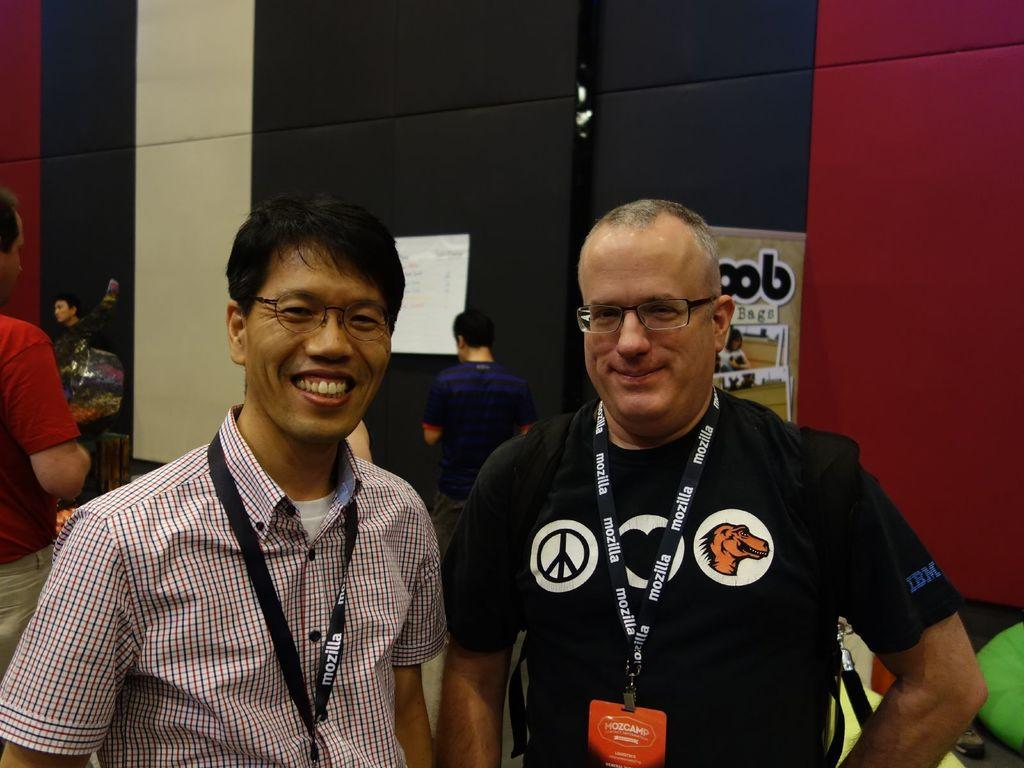How many men are in the foreground of the image? There are two men standing in the foreground of the image. What can be seen in the background of the image? There are people and posters in the background of the image. Can you describe any specific features of the background? It appears that there are curtains in the background of the image. What type of locket is the man wearing in the image? There is no mention of a locket or any jewelry in the image. --- Facts: 1. There is a person in the image. 2. The person is wearing a hat. 3. The person is holding a book. 4. The book has a title on the cover. 5. The background of the image is a park. Absurd Topics: elephant, piano, sixth Conversation: What is the main subject in the image? There is a person in the image. What is the person wearing in the image? The person is wearing a hat in the image. What is the person holding in the image? The person is holding a book in the image. What can be seen on the cover of the book? The book has a title on the cover in the image. What is the background of the image? The background of the image is a park. Reasoning: Let's think step by step in order to produce the conversation. We start by identifying the main subject of the image, which is the person. Then, we describe specific features of the person, such as the hat and the book they are holding. Next, we mention the title on the cover of the book, which is another detail about the image. Finally, we describe the background of the image, which is a park. Absurd Question/Answer: How many elephants can be seen playing the piano in the image? There are no elephants or pianos present in the image. 